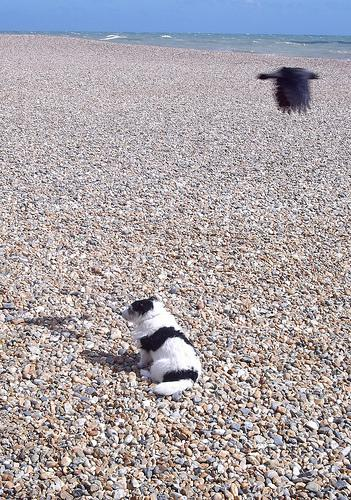Question: what color is the dog?
Choices:
A. Yellow.
B. Gray.
C. Tan.
D. Black and white.
Answer with the letter. Answer: D Question: what color is the bird?
Choices:
A. Red.
B. Black.
C. Yellow.
D. Blue.
Answer with the letter. Answer: B Question: what is the weather like?
Choices:
A. Warm.
B. Sunny.
C. Rainy.
D. Cold.
Answer with the letter. Answer: B Question: how many clouds are there?
Choices:
A. None.
B. One.
C. Two.
D. Three.
Answer with the letter. Answer: A 